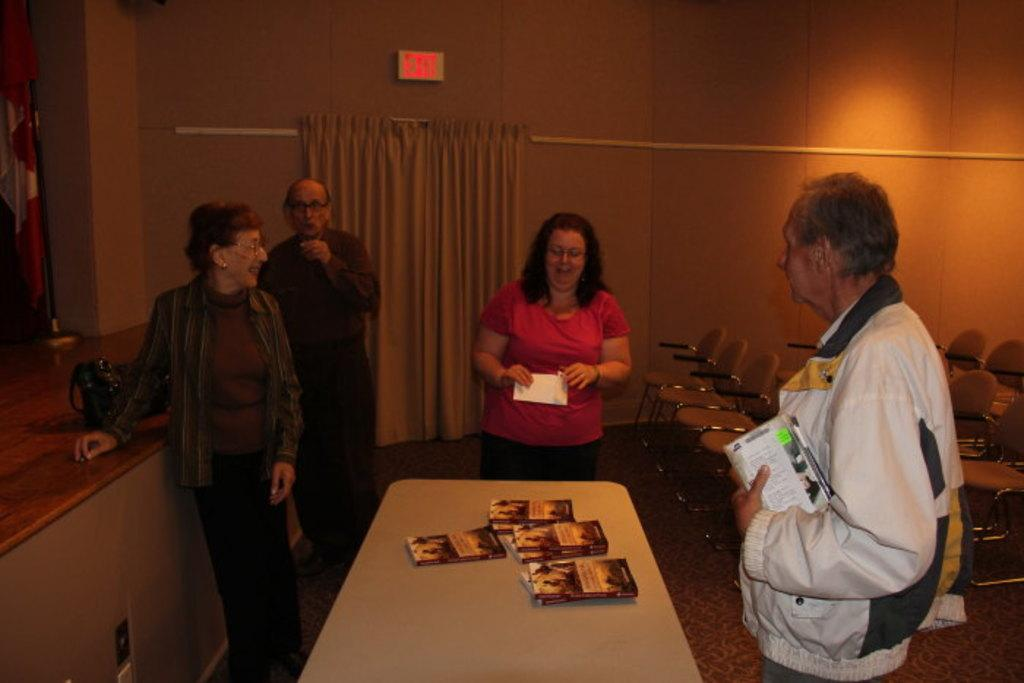How many people are standing in the image? There are four persons standing in the image. What is in front of the standing persons? There is a table in front of the standing persons. What can be found on the table? The table contains books. What can be seen in the background? There are chairs in the background. Did the earthquake cause the table to shake in the image? There is no indication of an earthquake or any shaking in the image. 